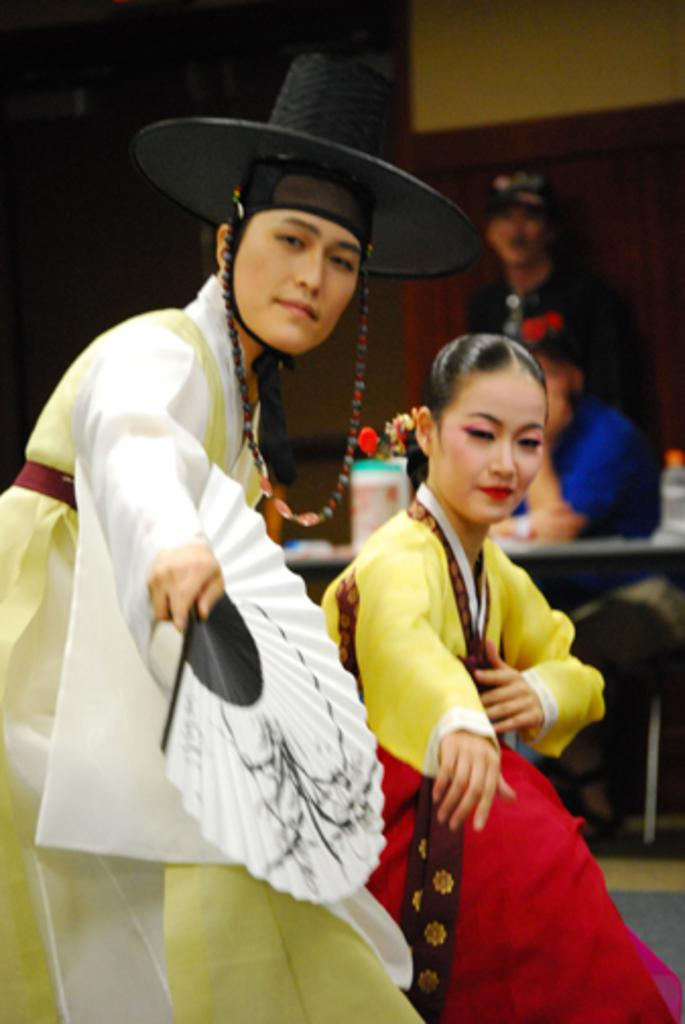Who can be seen in the image? There is a man and a woman in the image. What are the man and woman doing in the image? The man and woman are dancing. What can be seen in the background of the image? There is a wall in the background of the image. What type of metal can be seen in the shade in the image? There is no metal or shade present in the image; it features a man and a woman dancing in front of a wall. 